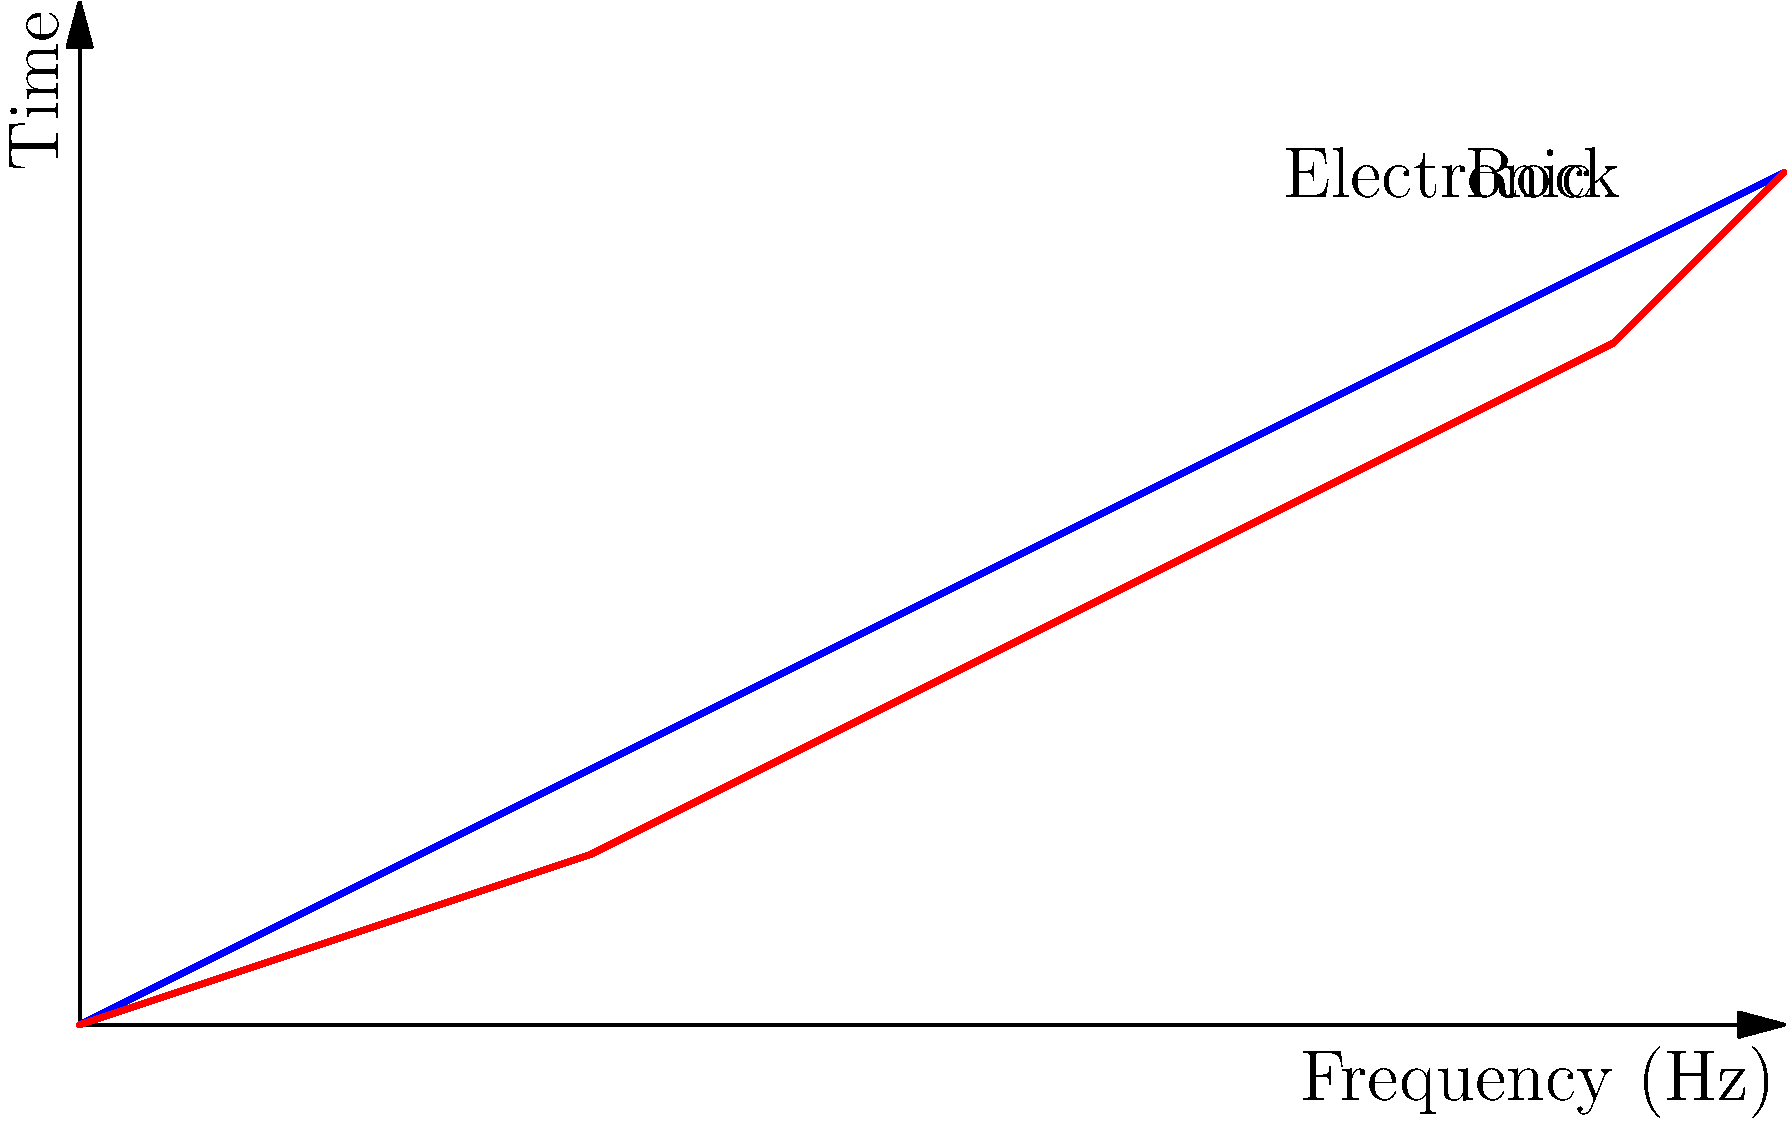Analyze the spectrograms of a guitar and a synthesizer shown in the image. How might these timbral differences contribute to the popularity of rock and electronic music genres in your weekly art challenges? Consider the frequency distribution and harmonic content in your response. To answer this question, let's analyze the spectrograms step-by-step:

1. Guitar (blue line):
   - Shows a more gradual increase in frequency over time
   - Implies a rich harmonic content with overtones
   - Characteristic of rock music's organic, warm sound

2. Synthesizer (red line):
   - Displays a steeper increase in frequency over time
   - Suggests more precise control over frequency content
   - Typical of electronic music's artificial, crisp sound

3. Timbral differences:
   - Guitar: More complex harmonic structure, creating a fuller sound
   - Synthesizer: Cleaner, more defined frequency bands

4. Impact on genre popularity:
   - Rock: The guitar's rich timbre appeals to listeners seeking emotional depth and rawness
   - Electronic: The synth's precise control allows for innovative sound design and futuristic aesthetics

5. Relevance to art challenges:
   - Rock-inspired challenges may attract artists drawn to expressive, organic forms
   - Electronic-inspired challenges might appeal to those interested in geometric, abstract designs

6. Frequency distribution:
   - Guitar: Wider spread of frequencies, inspiring diverse artistic interpretations
   - Synthesizer: More concentrated frequency bands, potentially leading to more focused artistic themes

7. Harmonic content:
   - Guitar: Complex harmonics could inspire layered, textured artworks
   - Synthesizer: Cleaner harmonics might encourage minimalist or precise artistic styles

These timbral differences can significantly influence the types of artworks created in genre-specific challenges, potentially affecting their popularity among participants.
Answer: Guitar's rich harmonics inspire diverse, textured art for rock challenges; synthesizer's precise frequencies encourage minimalist, futuristic designs for electronic challenges, appealing to different artistic preferences. 